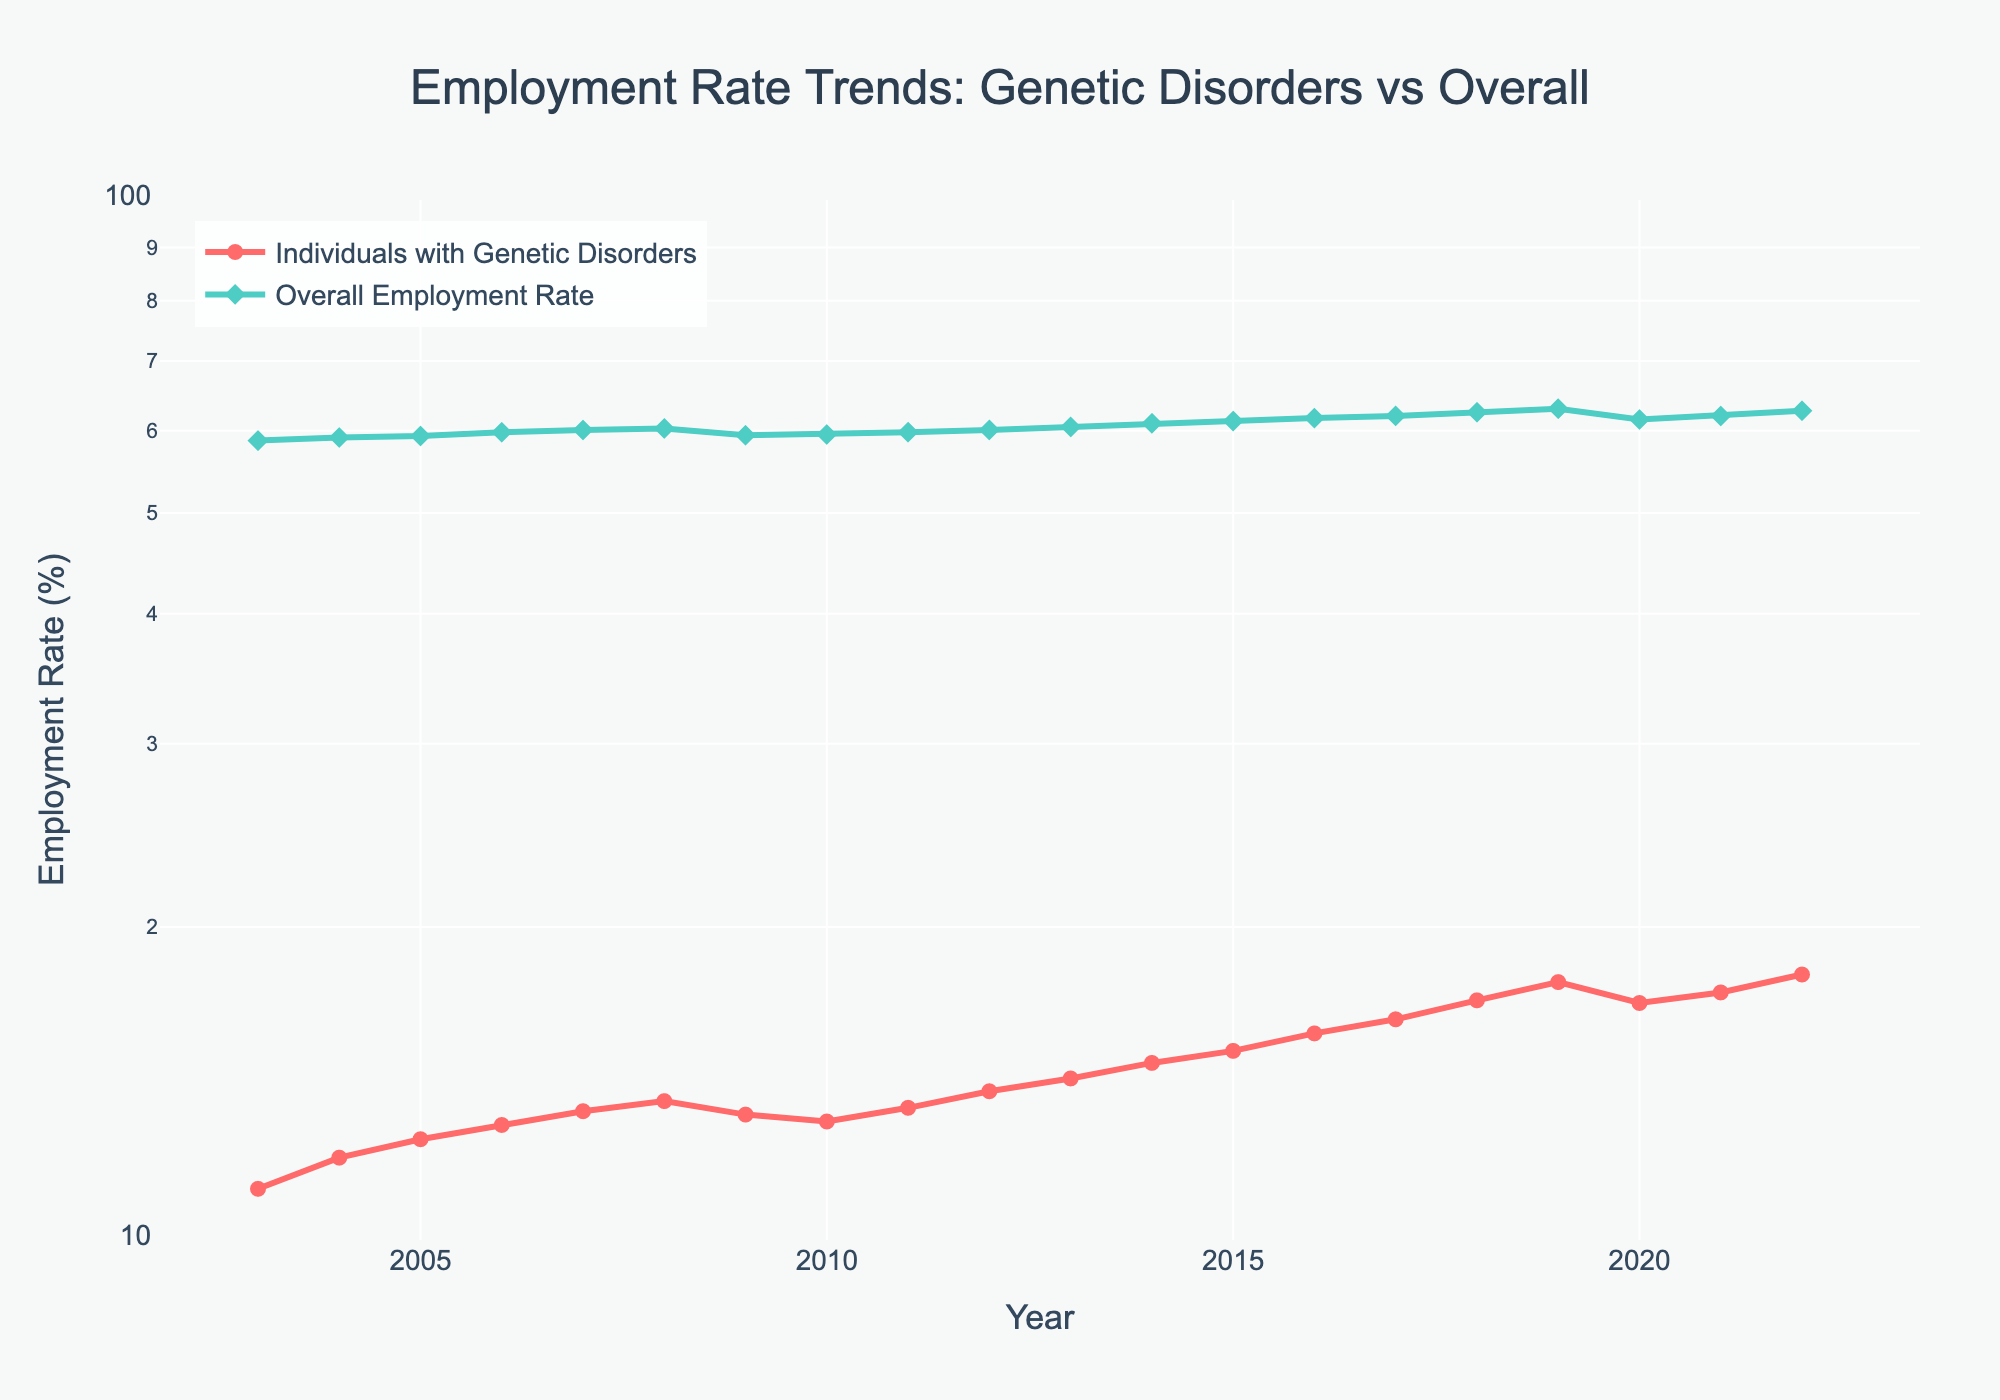What is the title of the plot? The title of the plot is usually the most prominent text placed at the top of the figure. It summarizes the main content and purpose of the plot.
Answer: Employment Rate Trends: Genetic Disorders vs Overall Which group had a higher employment rate in 2022? By examining the end of the lines in 2022 on the x-axis, we can compare the annotated points. The line with the higher y-value in 2022 represents the group with the higher employment rate.
Answer: Overall Employment Rate How does the employment rate trend for individuals with genetic disorders compare to the overall employment rate from 2003 to 2022? By visually tracing both lines from 2003 to 2022, we can observe the general direction (increase, decrease, or stable) of each group. We see that both the employment rates for individuals with genetic disorders and the overall employment rate have generally increased, but individuals with genetic disorders start at a much lower rate and show a steeper upward trend.
Answer: Both trends increased, but individuals with genetic disorders had a steeper increase What was the employment rate for individuals with genetic disorders in 2010? Find the year 2010 on the x-axis and look at the corresponding point for the line representing individuals with genetic disorders. The y-value at this point gives the employment rate.
Answer: 13.0% In which year did the employment rate for individuals with genetic disorders surpass 15%? By looking for the first point on the genetic disorders line where the y-value exceeds 15%, then tracing that point vertically down to the x-axis, we determine the corresponding year.
Answer: 2015 What is the overall employment rate trend between 2020 and 2021? Examine the section of the overall employment rate line between the points for 2020 and 2021. Observing whether the line goes up or down between these points will reveal the trend.
Answer: It increased During which years did individuals with genetic disorders experience a decline in the employment rate? Identify sections of the line for individuals with genetic disorders where the slope is downward. Trace these sections horizontally to find the corresponding years on the x-axis.
Answer: 2008-2009 and 2019-2020 What is the ratio of the employment rate of individuals with genetic disorders to the overall employment rate in 2018? Find the employment rates for both groups in 2018 on their respective lines. Divide the employment rate of individuals with genetic disorders by the overall employment rate to get the ratio.
Answer: 17.0/62.5 = approximately 0.272 How much did the employment rate for individuals with genetic disorders increase from 2003 to 2022? Subtract the employment rate for individuals with genetic disorders in 2003 from the rate in 2022.
Answer: 18.0 - 11.2 = 6.8% What was the greatest year-over-year increase in employment rate for individuals with genetic disorders, and when did it occur? To find the greatest year-over-year increase, calculate the difference in employment rate between each consecutive year for individuals with genetic disorders and identify the maximum value.
Answer: 17.7 - 17.0 = 0.7% (2018-2019) 